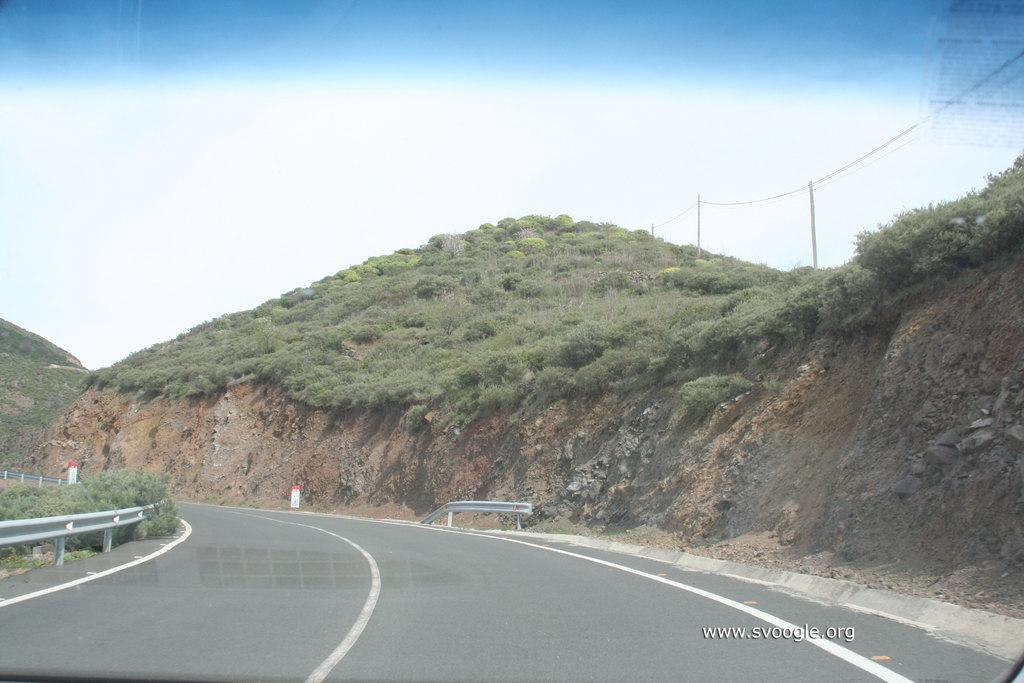What is the main feature of the landscape in the image? There is a road in the image. What type of natural features can be seen in the image? There are hills and trees in the image. What is the pole in the image used for? The pole in the image is likely used for supporting wires. What can be seen connected to the pole in the image? There are wires in the image. What type of beast is visible in the image? There is no beast present in the image. What team is responsible for maintaining the road in the image? There is no team mentioned or implied in the image; it only shows a road, hills, a pole, wires, and trees. 